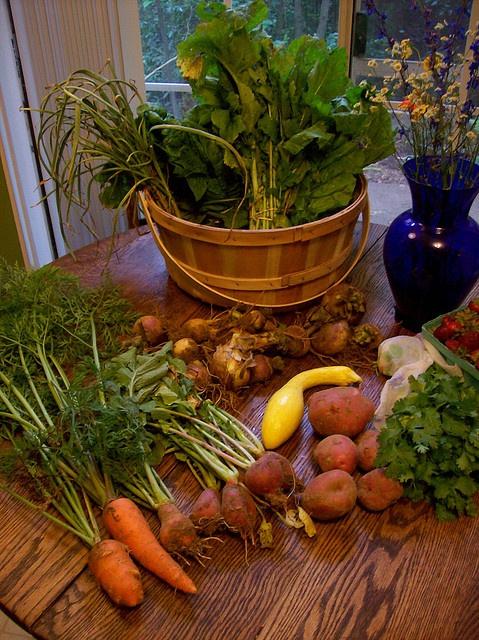Describe the objects in this image and their specific colors. I can see dining table in gray, maroon, black, olive, and brown tones, potted plant in gray, black, olive, maroon, and darkgreen tones, vase in gray, black, navy, and maroon tones, carrot in gray, red, brown, and maroon tones, and carrot in gray, red, brown, and maroon tones in this image. 